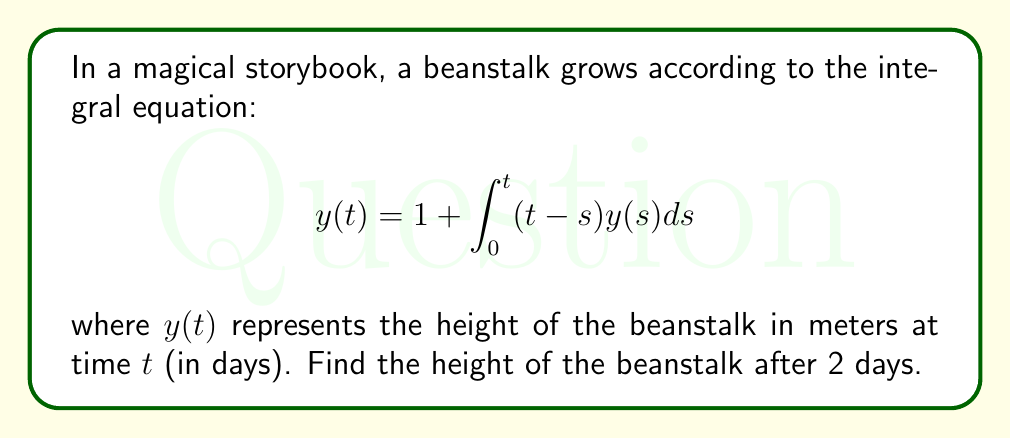Provide a solution to this math problem. To solve this integral equation, we can use the method of successive approximations:

1) Start with the initial approximation $y_0(t) = 1$

2) Substitute this into the integral equation to get the next approximation:

   $$y_1(t) = 1 + \int_0^t (t-s) \cdot 1 ds = 1 + \left[ts - \frac{s^2}{2}\right]_0^t = 1 + \frac{t^2}{2}$$

3) Use $y_1(t)$ to find $y_2(t)$:

   $$y_2(t) = 1 + \int_0^t (t-s)(1 + \frac{s^2}{2})ds$$
   $$= 1 + \int_0^t (t-s)ds + \frac{1}{2}\int_0^t (t-s)s^2ds$$
   $$= 1 + \frac{t^2}{2} + \frac{1}{2}\left[ts^3 - \frac{s^4}{4}\right]_0^t$$
   $$= 1 + \frac{t^2}{2} + \frac{t^4}{8}$$

4) We can see a pattern forming. The general solution is:

   $$y(t) = 1 + \frac{t^2}{2!} + \frac{t^4}{4!} + \frac{t^6}{6!} + ...$$

5) This is the series expansion of $\cosh(t)$. Therefore, the exact solution is:

   $$y(t) = \cosh(t)$$

6) To find the height after 2 days, we calculate:

   $$y(2) = \cosh(2) \approx 3.7622$$
Answer: $\cosh(2) \approx 3.7622$ meters 